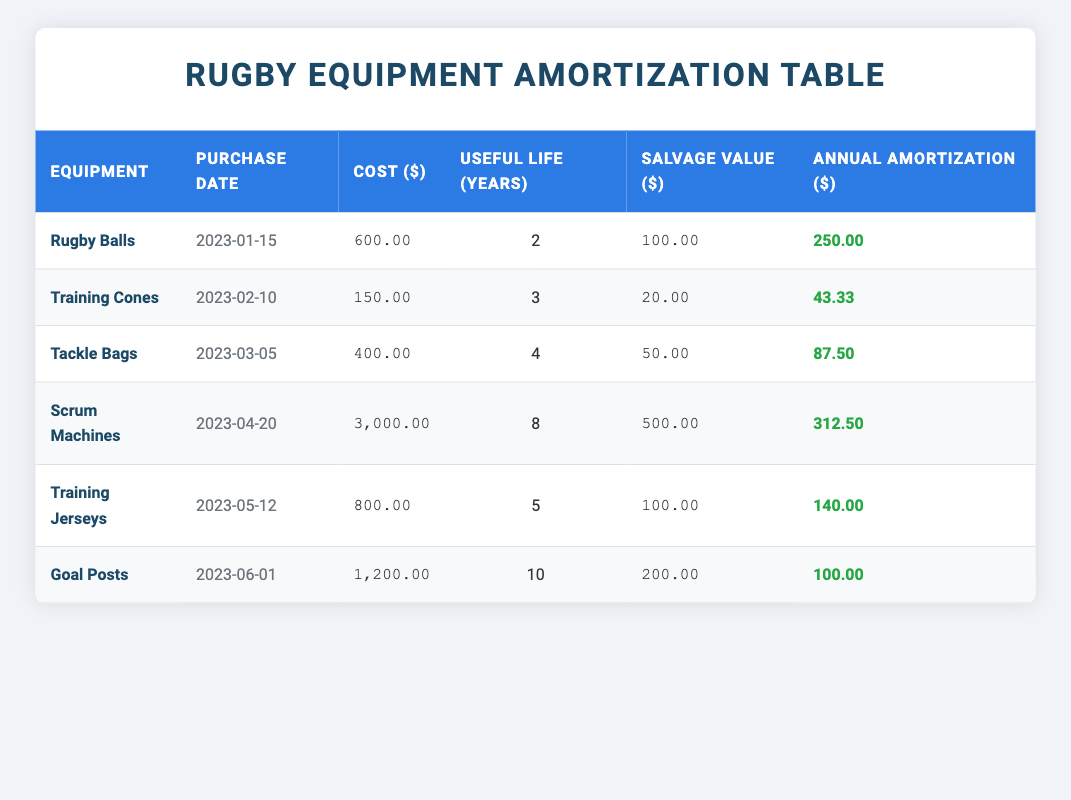What is the purchase date of the Rugby Balls? The table lists the Rugby Balls along with its purchase date. The date provided next to Rugby Balls is 2023-01-15.
Answer: 2023-01-15 What is the cost of Training Cones? The table shows the cost associated with each equipment item. For Training Cones, the cost is listed as 150.00.
Answer: 150.00 How much is the annual amortization for Scrum Machines? The Scrum Machines have an annual amortization listed in the table. The amount for Scrum Machines is 312.50.
Answer: 312.50 Which equipment has the longest useful life? The table provides the useful life for each piece of equipment. Goal Posts have the longest useful life at 10 years.
Answer: Goal Posts What is the average annual amortization for all the equipment? To find the average, sum the annual amortization values (250.00 + 43.33 + 87.50 + 312.50 + 140.00 + 100.00 = 933.33) and divide by the number of equipment items (6). Therefore, the average is 933.33 / 6 = 155.56.
Answer: 155.56 Are training jerseys costlier than training cones? Comparing the costs, Training Jerseys costs 800.00 and Training Cones costs 150.00. Since 800.00 is greater than 150.00, the answer is yes.
Answer: Yes How much total cost is incurred for Tackle Bags and Training Cones combined? Adding the costs of Tackle Bags (400.00) and Training Cones (150.00), we get 400.00 + 150.00 = 550.00 as the total cost for both.
Answer: 550.00 Is the salvage value of Scrum Machines greater than that of Rugby Balls? The salvage value for Scrum Machines is 500.00 and for Rugby Balls is 100.00. Since 500.00 is greater than 100.00, the answer is yes.
Answer: Yes What is the difference in annual amortization between Tackle Bags and Training Jerseys? The annual amortization for Tackle Bags is 87.50 and for Training Jerseys is 140.00. The difference is calculated as 140.00 - 87.50 = 52.50.
Answer: 52.50 